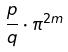Convert formula to latex. <formula><loc_0><loc_0><loc_500><loc_500>\frac { p } { q } \cdot \pi ^ { 2 m }</formula> 